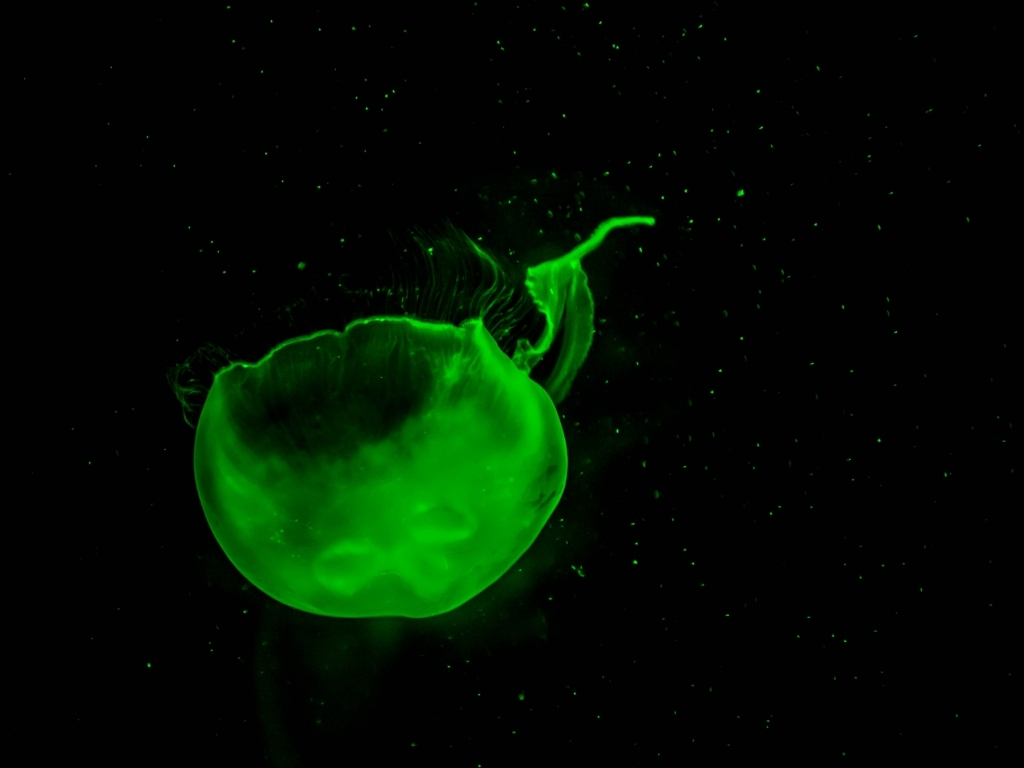What kind of environment do jellyfish like this typically inhabit, and are they dangerous to humans? Jellyfish like the one in the image are typically found in the open sea, although some species may inhabit shallower coastal waters. Many jellyfish are harmless to humans, but some species can sting and cause reactions ranging from mild discomfort to severe pain or allergic reactions. It's essential to exercise caution and respect when encountering them in their natural habitat. 